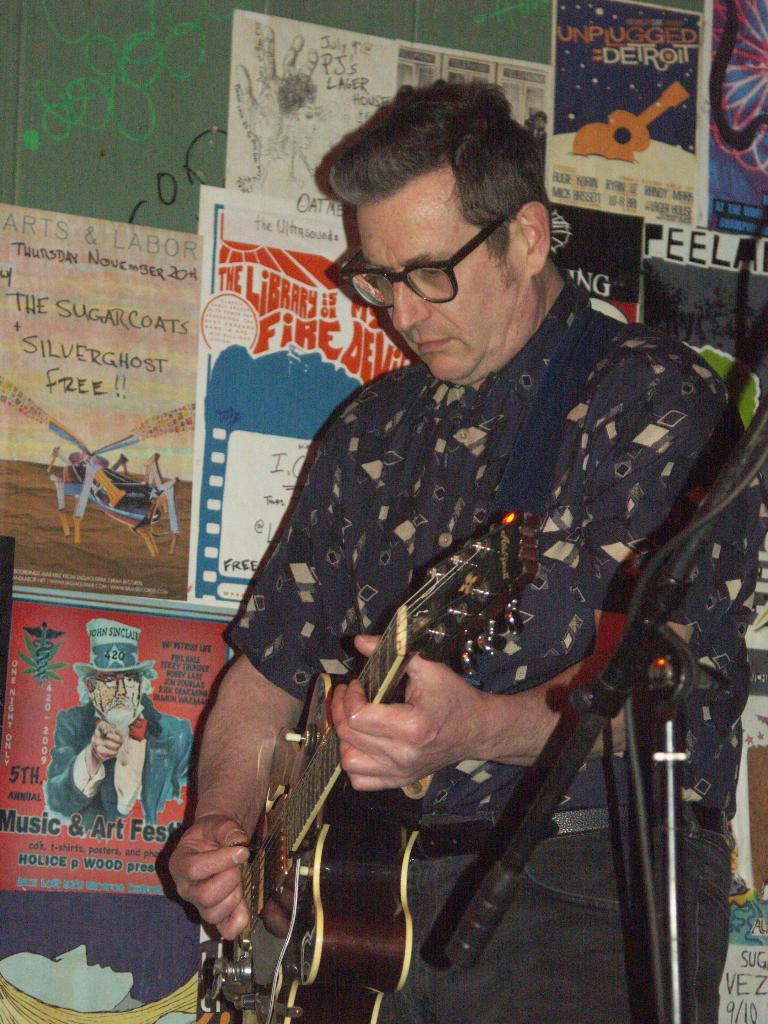Who is the main subject in the image? There is a man in the image. What is the man wearing? The man is wearing spectacles. What is the man doing in the image? The man is playing a guitar. What can be seen on the wall in the image? There are posters on the wall. What type of poison is the man using to play the guitar in the image? There is no poison present in the image, and the man is playing the guitar without any poison. What type of locket is the man wearing in the image? There is no locket visible in the image; the man is only wearing spectacles. 